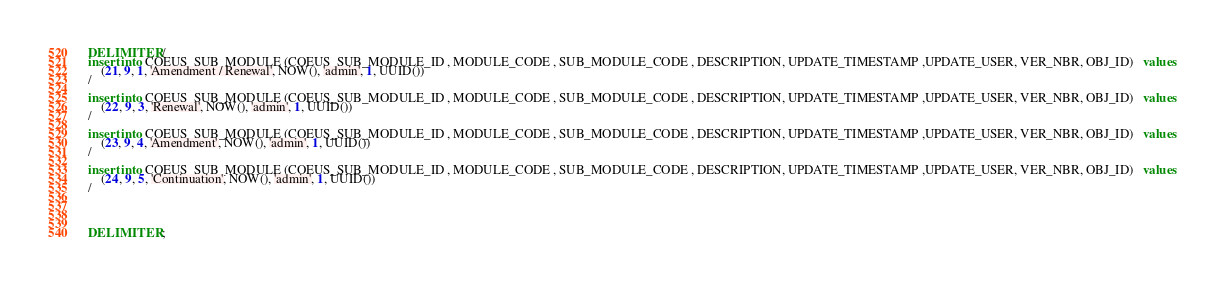<code> <loc_0><loc_0><loc_500><loc_500><_SQL_>DELIMITER /
insert into COEUS_SUB_MODULE (COEUS_SUB_MODULE_ID , MODULE_CODE , SUB_MODULE_CODE , DESCRIPTION, UPDATE_TIMESTAMP ,UPDATE_USER, VER_NBR, OBJ_ID)   values 
	(21, 9, 1, 'Amendment / Renewal', NOW(), 'admin', 1, UUID())
/

insert into COEUS_SUB_MODULE (COEUS_SUB_MODULE_ID , MODULE_CODE , SUB_MODULE_CODE , DESCRIPTION, UPDATE_TIMESTAMP ,UPDATE_USER, VER_NBR, OBJ_ID)   values 
	(22, 9, 3, 'Renewal', NOW(), 'admin', 1, UUID())
/

insert into COEUS_SUB_MODULE (COEUS_SUB_MODULE_ID , MODULE_CODE , SUB_MODULE_CODE , DESCRIPTION, UPDATE_TIMESTAMP ,UPDATE_USER, VER_NBR, OBJ_ID)   values 
	(23, 9, 4, 'Amendment', NOW(), 'admin', 1, UUID())
/

insert into COEUS_SUB_MODULE (COEUS_SUB_MODULE_ID , MODULE_CODE , SUB_MODULE_CODE , DESCRIPTION, UPDATE_TIMESTAMP ,UPDATE_USER, VER_NBR, OBJ_ID)   values 
	(24, 9, 5, 'Continuation', NOW(), 'admin', 1, UUID())
/




DELIMITER ;
</code> 